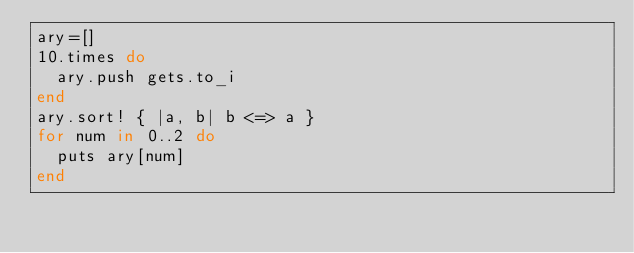<code> <loc_0><loc_0><loc_500><loc_500><_Ruby_>ary=[]
10.times do
  ary.push gets.to_i
end
ary.sort! { |a, b| b <=> a }
for num in 0..2 do
  puts ary[num]
end</code> 